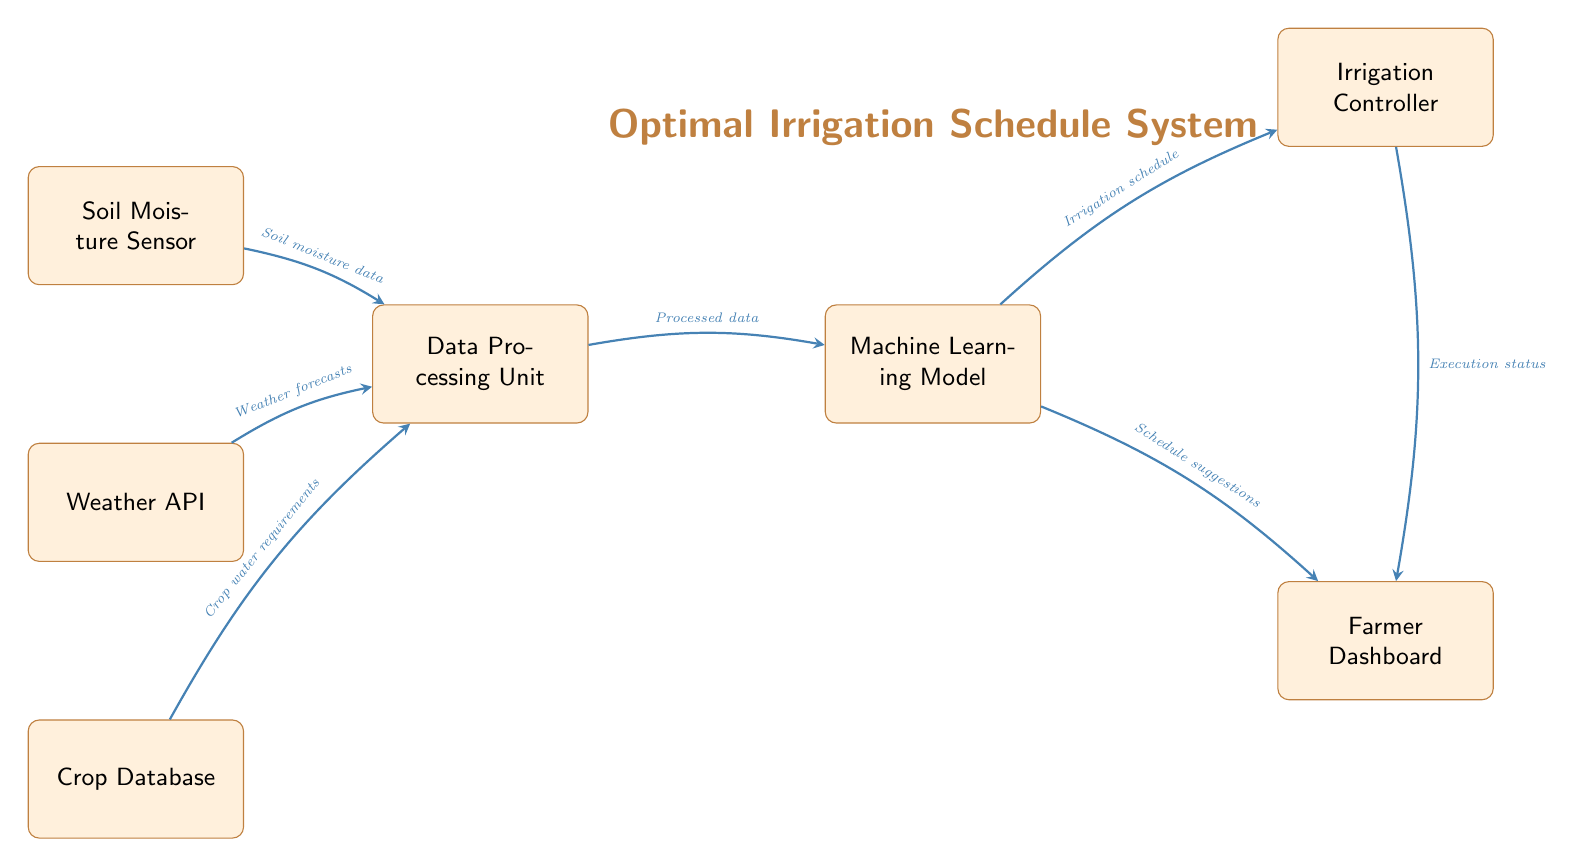What is the first input to the Data Processing Unit? The first input to the Data Processing Unit is from the Soil Moisture Sensor, which provides soil moisture data.
Answer: Soil moisture data How many nodes are present in the diagram? To find the number of nodes, we count all the distinct boxes in the diagram. There are seven nodes displayed: Soil Moisture Sensor, Weather API, Crop Database, Data Processing Unit, Machine Learning Model, Irrigation Controller, and Farmer Dashboard.
Answer: Seven What does the Irrigation Controller output? The Irrigation Controller outputs the execution status. This is indicated by the arrow leading from the Irrigation Controller to the Farmer Dashboard labeled as such.
Answer: Execution status Which node receives data from both the Soil Moisture Sensor and Weather API? The Data Processing Unit receives data from both the Soil Moisture Sensor and the Weather API based on the arrows connecting those nodes.
Answer: Data Processing Unit What type of data does the Crop Database provide to the Data Processing Unit? The Crop Database provides crop water requirements to the Data Processing Unit, as shown by the labeled arrow between these two nodes.
Answer: Crop water requirements What is the relationship between the Machine Learning Model and the Irrigation Controller? The relationship is that the Machine Learning Model provides the irrigation schedule to the Irrigation Controller, indicated by the directed arrow labeled with that information.
Answer: Irrigation schedule How does the Farmer Dashboard receive information from the Machine Learning Model? The Farmer Dashboard receives schedule suggestions from the Machine Learning Model, as indicated by the directed arrow labeled accordingly.
Answer: Schedule suggestions What is the main purpose of the Optimal Irrigation Schedule System? The main purpose is to improve water usage and crop health by suggesting the most efficient irrigation schedule based on various inputs.
Answer: Improve water usage and crop health 